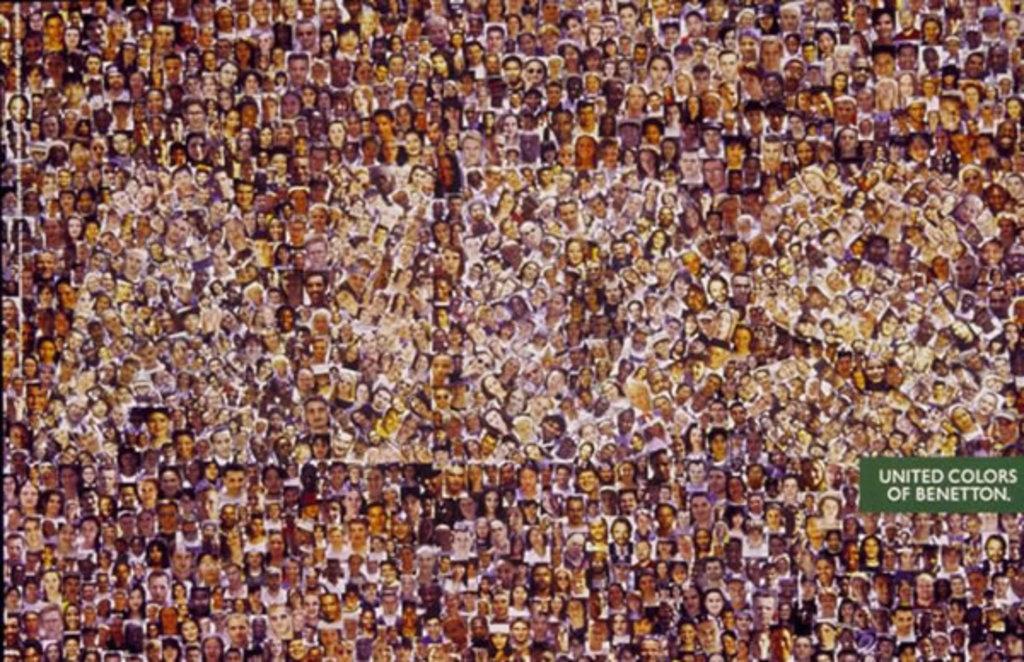In one or two sentences, can you explain what this image depicts? There is collage of many people. There is a green tag at the right on which 'united colors of benetton' is written. There is a watermark 'aids'. 